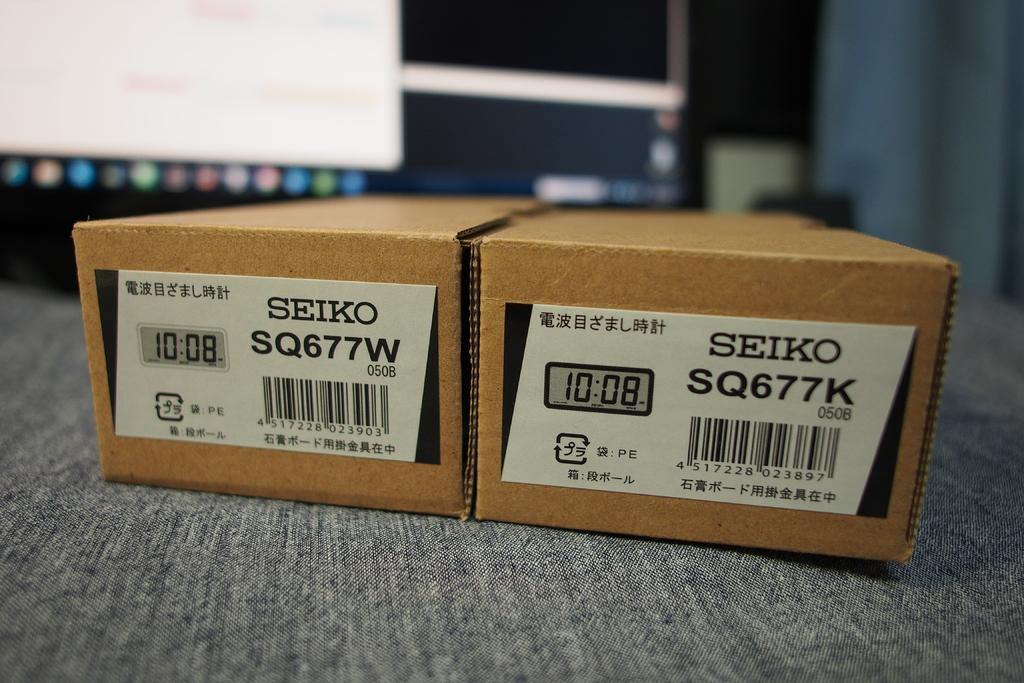<image>
Summarize the visual content of the image. Two cardboard boxes containing Seiko products sit on a gray cloth. 